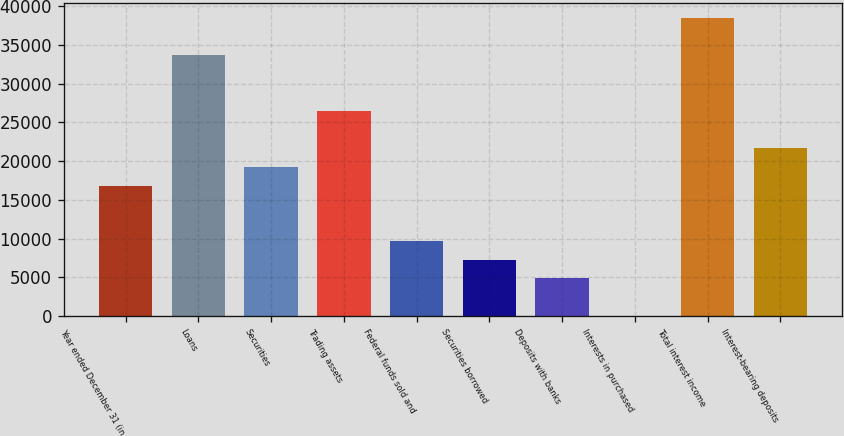Convert chart. <chart><loc_0><loc_0><loc_500><loc_500><bar_chart><fcel>Year ended December 31 (in<fcel>Loans<fcel>Securities<fcel>Trading assets<fcel>Federal funds sold and<fcel>Securities borrowed<fcel>Deposits with banks<fcel>Interests in purchased<fcel>Total interest income<fcel>Interest-bearing deposits<nl><fcel>16850<fcel>33636<fcel>19248<fcel>26442<fcel>9656<fcel>7258<fcel>4860<fcel>64<fcel>38432<fcel>21646<nl></chart> 